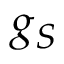<formula> <loc_0><loc_0><loc_500><loc_500>g _ { S }</formula> 